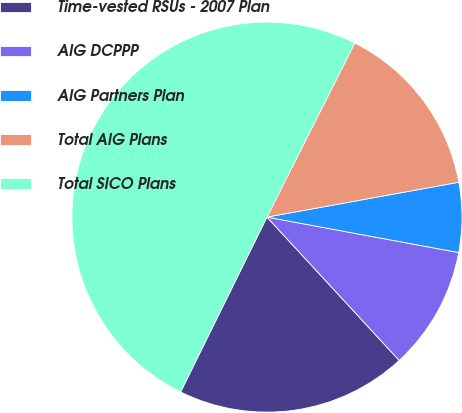Convert chart to OTSL. <chart><loc_0><loc_0><loc_500><loc_500><pie_chart><fcel>Time-vested RSUs - 2007 Plan<fcel>AIG DCPPP<fcel>AIG Partners Plan<fcel>Total AIG Plans<fcel>Total SICO Plans<nl><fcel>19.16%<fcel>10.23%<fcel>5.77%<fcel>14.7%<fcel>50.14%<nl></chart> 